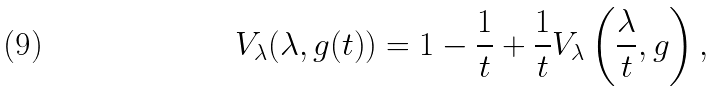<formula> <loc_0><loc_0><loc_500><loc_500>V _ { \lambda } ( \lambda , { g ( t ) } ) = 1 - \frac { 1 } { t } + \frac { 1 } { t } V _ { \lambda } \left ( \frac { \lambda } { t } , g \right ) ,</formula> 